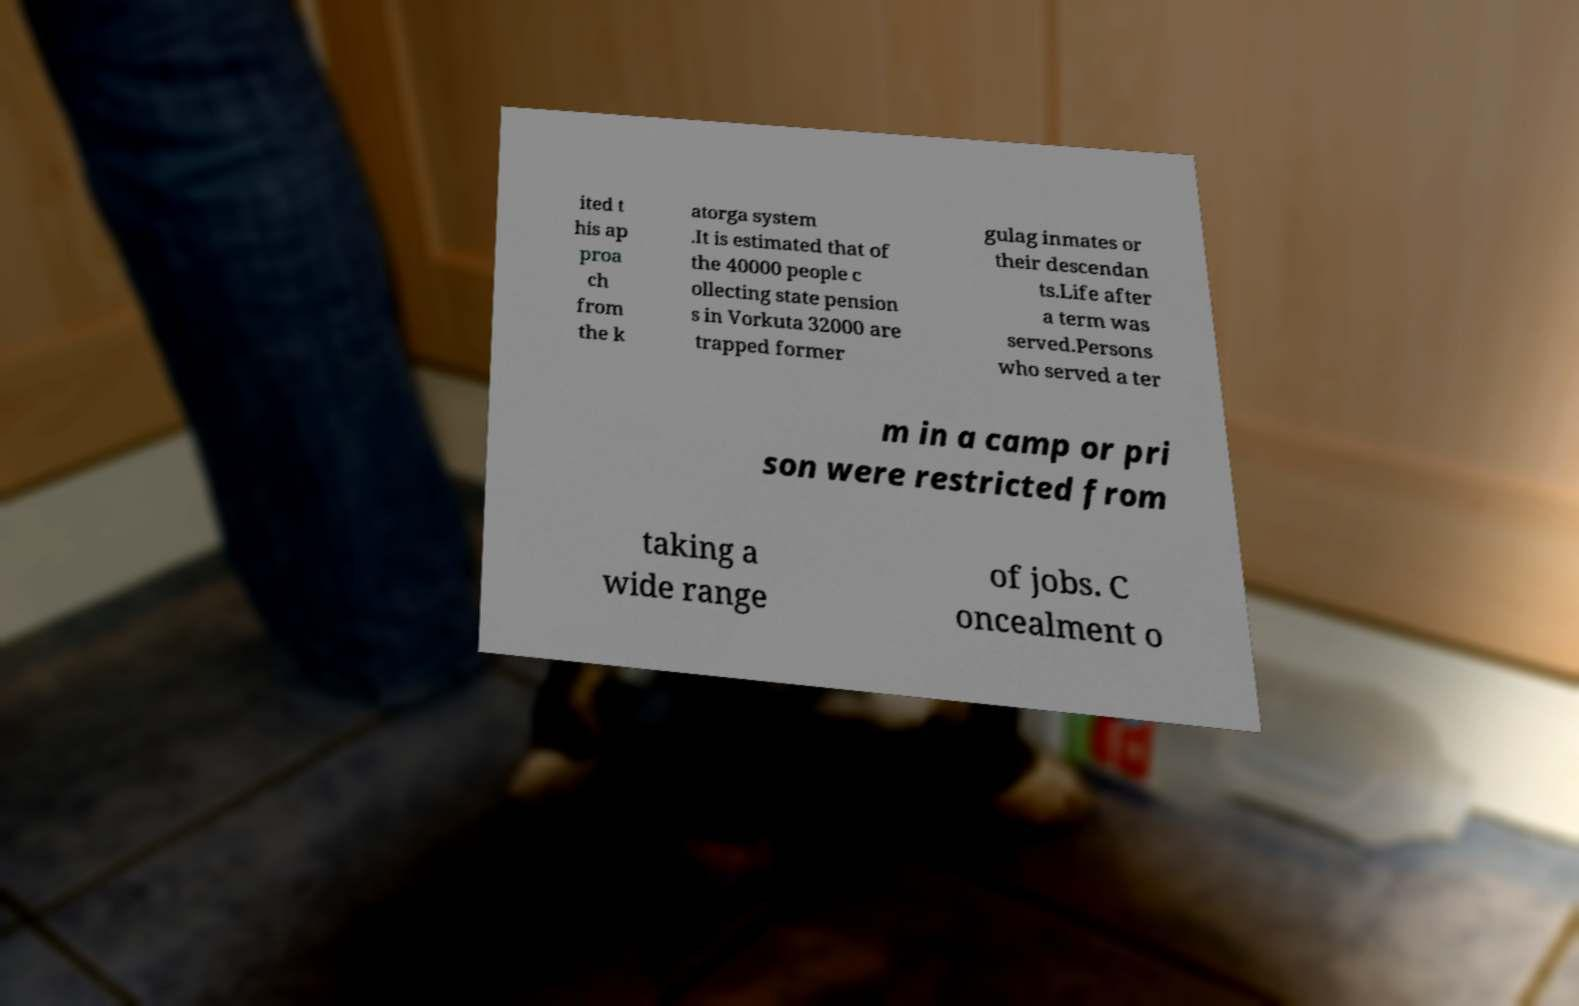For documentation purposes, I need the text within this image transcribed. Could you provide that? ited t his ap proa ch from the k atorga system .It is estimated that of the 40000 people c ollecting state pension s in Vorkuta 32000 are trapped former gulag inmates or their descendan ts.Life after a term was served.Persons who served a ter m in a camp or pri son were restricted from taking a wide range of jobs. C oncealment o 